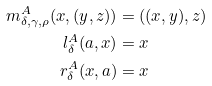Convert formula to latex. <formula><loc_0><loc_0><loc_500><loc_500>m _ { \delta , \gamma , \rho } ^ { A } ( x , ( y , z ) ) & = ( ( x , y ) , z ) \\ l _ { \delta } ^ { A } ( a , x ) & = x \\ r _ { \delta } ^ { A } ( x , a ) & = x</formula> 